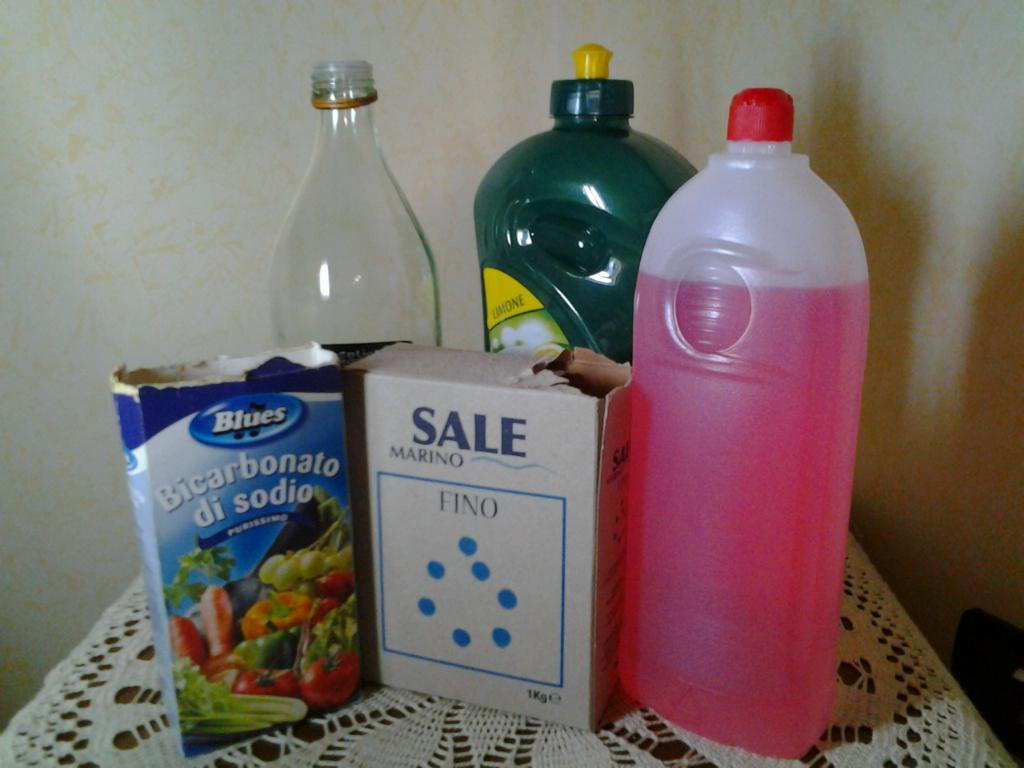<image>
Render a clear and concise summary of the photo. the word sale is on the front of a box 